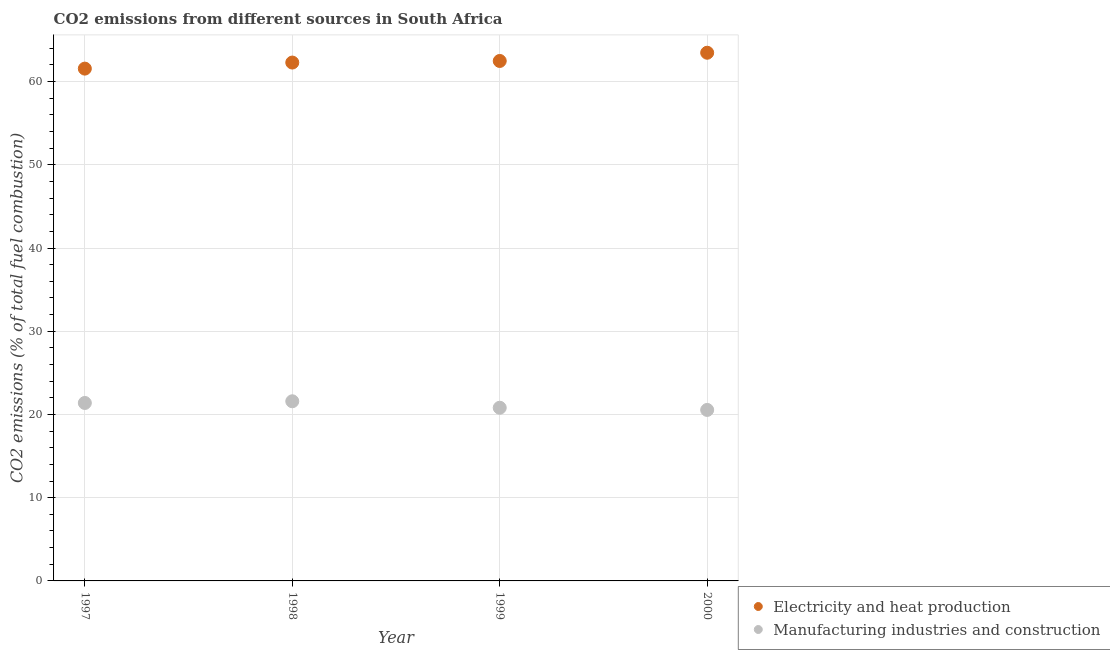Is the number of dotlines equal to the number of legend labels?
Provide a short and direct response. Yes. What is the co2 emissions due to electricity and heat production in 1999?
Provide a short and direct response. 62.47. Across all years, what is the maximum co2 emissions due to manufacturing industries?
Provide a succinct answer. 21.58. Across all years, what is the minimum co2 emissions due to manufacturing industries?
Offer a very short reply. 20.54. In which year was the co2 emissions due to electricity and heat production minimum?
Provide a succinct answer. 1997. What is the total co2 emissions due to manufacturing industries in the graph?
Your answer should be compact. 84.32. What is the difference between the co2 emissions due to manufacturing industries in 1997 and that in 1999?
Your answer should be very brief. 0.57. What is the difference between the co2 emissions due to manufacturing industries in 1997 and the co2 emissions due to electricity and heat production in 2000?
Your answer should be compact. -42.08. What is the average co2 emissions due to electricity and heat production per year?
Offer a very short reply. 62.44. In the year 1998, what is the difference between the co2 emissions due to manufacturing industries and co2 emissions due to electricity and heat production?
Keep it short and to the point. -40.7. In how many years, is the co2 emissions due to manufacturing industries greater than 36 %?
Give a very brief answer. 0. What is the ratio of the co2 emissions due to manufacturing industries in 1997 to that in 1999?
Your answer should be compact. 1.03. What is the difference between the highest and the second highest co2 emissions due to manufacturing industries?
Give a very brief answer. 0.2. What is the difference between the highest and the lowest co2 emissions due to manufacturing industries?
Ensure brevity in your answer.  1.04. Does the co2 emissions due to electricity and heat production monotonically increase over the years?
Your answer should be very brief. Yes. How many dotlines are there?
Provide a short and direct response. 2. How many years are there in the graph?
Make the answer very short. 4. What is the difference between two consecutive major ticks on the Y-axis?
Give a very brief answer. 10. Where does the legend appear in the graph?
Provide a short and direct response. Bottom right. How many legend labels are there?
Make the answer very short. 2. What is the title of the graph?
Provide a short and direct response. CO2 emissions from different sources in South Africa. What is the label or title of the X-axis?
Give a very brief answer. Year. What is the label or title of the Y-axis?
Provide a short and direct response. CO2 emissions (% of total fuel combustion). What is the CO2 emissions (% of total fuel combustion) of Electricity and heat production in 1997?
Keep it short and to the point. 61.55. What is the CO2 emissions (% of total fuel combustion) in Manufacturing industries and construction in 1997?
Provide a short and direct response. 21.38. What is the CO2 emissions (% of total fuel combustion) of Electricity and heat production in 1998?
Your answer should be very brief. 62.28. What is the CO2 emissions (% of total fuel combustion) of Manufacturing industries and construction in 1998?
Keep it short and to the point. 21.58. What is the CO2 emissions (% of total fuel combustion) of Electricity and heat production in 1999?
Keep it short and to the point. 62.47. What is the CO2 emissions (% of total fuel combustion) in Manufacturing industries and construction in 1999?
Your answer should be compact. 20.81. What is the CO2 emissions (% of total fuel combustion) in Electricity and heat production in 2000?
Give a very brief answer. 63.46. What is the CO2 emissions (% of total fuel combustion) of Manufacturing industries and construction in 2000?
Your answer should be very brief. 20.54. Across all years, what is the maximum CO2 emissions (% of total fuel combustion) in Electricity and heat production?
Offer a very short reply. 63.46. Across all years, what is the maximum CO2 emissions (% of total fuel combustion) of Manufacturing industries and construction?
Offer a very short reply. 21.58. Across all years, what is the minimum CO2 emissions (% of total fuel combustion) of Electricity and heat production?
Give a very brief answer. 61.55. Across all years, what is the minimum CO2 emissions (% of total fuel combustion) in Manufacturing industries and construction?
Provide a succinct answer. 20.54. What is the total CO2 emissions (% of total fuel combustion) in Electricity and heat production in the graph?
Provide a succinct answer. 249.77. What is the total CO2 emissions (% of total fuel combustion) in Manufacturing industries and construction in the graph?
Keep it short and to the point. 84.32. What is the difference between the CO2 emissions (% of total fuel combustion) of Electricity and heat production in 1997 and that in 1998?
Offer a very short reply. -0.73. What is the difference between the CO2 emissions (% of total fuel combustion) of Manufacturing industries and construction in 1997 and that in 1998?
Give a very brief answer. -0.2. What is the difference between the CO2 emissions (% of total fuel combustion) of Electricity and heat production in 1997 and that in 1999?
Keep it short and to the point. -0.92. What is the difference between the CO2 emissions (% of total fuel combustion) in Manufacturing industries and construction in 1997 and that in 1999?
Make the answer very short. 0.57. What is the difference between the CO2 emissions (% of total fuel combustion) of Electricity and heat production in 1997 and that in 2000?
Your response must be concise. -1.91. What is the difference between the CO2 emissions (% of total fuel combustion) of Manufacturing industries and construction in 1997 and that in 2000?
Give a very brief answer. 0.84. What is the difference between the CO2 emissions (% of total fuel combustion) in Electricity and heat production in 1998 and that in 1999?
Your answer should be compact. -0.19. What is the difference between the CO2 emissions (% of total fuel combustion) in Manufacturing industries and construction in 1998 and that in 1999?
Provide a succinct answer. 0.78. What is the difference between the CO2 emissions (% of total fuel combustion) of Electricity and heat production in 1998 and that in 2000?
Give a very brief answer. -1.18. What is the difference between the CO2 emissions (% of total fuel combustion) of Manufacturing industries and construction in 1998 and that in 2000?
Provide a succinct answer. 1.04. What is the difference between the CO2 emissions (% of total fuel combustion) of Electricity and heat production in 1999 and that in 2000?
Provide a short and direct response. -0.99. What is the difference between the CO2 emissions (% of total fuel combustion) of Manufacturing industries and construction in 1999 and that in 2000?
Your response must be concise. 0.26. What is the difference between the CO2 emissions (% of total fuel combustion) of Electricity and heat production in 1997 and the CO2 emissions (% of total fuel combustion) of Manufacturing industries and construction in 1998?
Offer a very short reply. 39.97. What is the difference between the CO2 emissions (% of total fuel combustion) of Electricity and heat production in 1997 and the CO2 emissions (% of total fuel combustion) of Manufacturing industries and construction in 1999?
Make the answer very short. 40.75. What is the difference between the CO2 emissions (% of total fuel combustion) of Electricity and heat production in 1997 and the CO2 emissions (% of total fuel combustion) of Manufacturing industries and construction in 2000?
Your response must be concise. 41.01. What is the difference between the CO2 emissions (% of total fuel combustion) in Electricity and heat production in 1998 and the CO2 emissions (% of total fuel combustion) in Manufacturing industries and construction in 1999?
Provide a succinct answer. 41.47. What is the difference between the CO2 emissions (% of total fuel combustion) in Electricity and heat production in 1998 and the CO2 emissions (% of total fuel combustion) in Manufacturing industries and construction in 2000?
Your response must be concise. 41.74. What is the difference between the CO2 emissions (% of total fuel combustion) in Electricity and heat production in 1999 and the CO2 emissions (% of total fuel combustion) in Manufacturing industries and construction in 2000?
Keep it short and to the point. 41.93. What is the average CO2 emissions (% of total fuel combustion) of Electricity and heat production per year?
Your answer should be very brief. 62.44. What is the average CO2 emissions (% of total fuel combustion) in Manufacturing industries and construction per year?
Give a very brief answer. 21.08. In the year 1997, what is the difference between the CO2 emissions (% of total fuel combustion) in Electricity and heat production and CO2 emissions (% of total fuel combustion) in Manufacturing industries and construction?
Ensure brevity in your answer.  40.17. In the year 1998, what is the difference between the CO2 emissions (% of total fuel combustion) of Electricity and heat production and CO2 emissions (% of total fuel combustion) of Manufacturing industries and construction?
Give a very brief answer. 40.7. In the year 1999, what is the difference between the CO2 emissions (% of total fuel combustion) of Electricity and heat production and CO2 emissions (% of total fuel combustion) of Manufacturing industries and construction?
Your response must be concise. 41.67. In the year 2000, what is the difference between the CO2 emissions (% of total fuel combustion) in Electricity and heat production and CO2 emissions (% of total fuel combustion) in Manufacturing industries and construction?
Make the answer very short. 42.92. What is the ratio of the CO2 emissions (% of total fuel combustion) in Electricity and heat production in 1997 to that in 1998?
Provide a succinct answer. 0.99. What is the ratio of the CO2 emissions (% of total fuel combustion) in Manufacturing industries and construction in 1997 to that in 1998?
Offer a terse response. 0.99. What is the ratio of the CO2 emissions (% of total fuel combustion) in Electricity and heat production in 1997 to that in 1999?
Keep it short and to the point. 0.99. What is the ratio of the CO2 emissions (% of total fuel combustion) in Manufacturing industries and construction in 1997 to that in 1999?
Your answer should be very brief. 1.03. What is the ratio of the CO2 emissions (% of total fuel combustion) of Electricity and heat production in 1997 to that in 2000?
Provide a succinct answer. 0.97. What is the ratio of the CO2 emissions (% of total fuel combustion) of Manufacturing industries and construction in 1997 to that in 2000?
Ensure brevity in your answer.  1.04. What is the ratio of the CO2 emissions (% of total fuel combustion) in Manufacturing industries and construction in 1998 to that in 1999?
Provide a short and direct response. 1.04. What is the ratio of the CO2 emissions (% of total fuel combustion) in Electricity and heat production in 1998 to that in 2000?
Offer a very short reply. 0.98. What is the ratio of the CO2 emissions (% of total fuel combustion) in Manufacturing industries and construction in 1998 to that in 2000?
Provide a succinct answer. 1.05. What is the ratio of the CO2 emissions (% of total fuel combustion) in Electricity and heat production in 1999 to that in 2000?
Give a very brief answer. 0.98. What is the ratio of the CO2 emissions (% of total fuel combustion) of Manufacturing industries and construction in 1999 to that in 2000?
Make the answer very short. 1.01. What is the difference between the highest and the second highest CO2 emissions (% of total fuel combustion) of Manufacturing industries and construction?
Keep it short and to the point. 0.2. What is the difference between the highest and the lowest CO2 emissions (% of total fuel combustion) of Electricity and heat production?
Provide a succinct answer. 1.91. What is the difference between the highest and the lowest CO2 emissions (% of total fuel combustion) in Manufacturing industries and construction?
Provide a short and direct response. 1.04. 